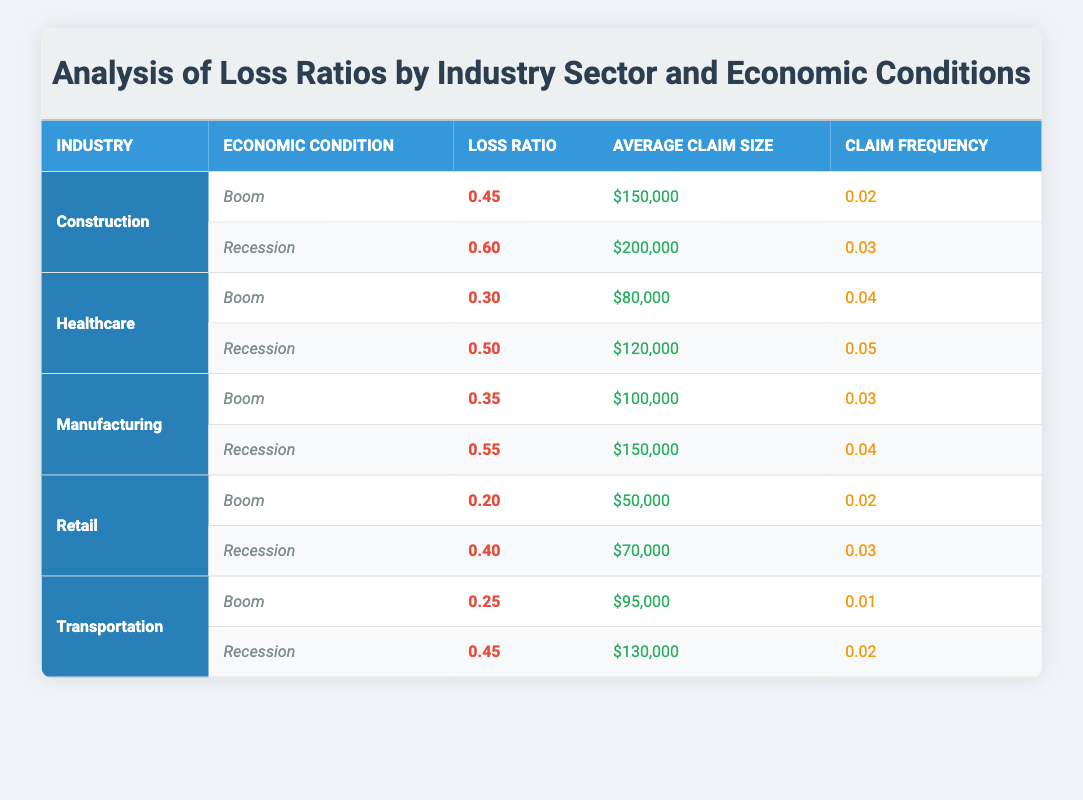What is the loss ratio for the Healthcare industry during a Boom? The table shows that for the Healthcare industry under Boom economic conditions, the loss ratio is listed directly as 0.30.
Answer: 0.30 What is the average claim size for the Construction industry during a Recession? Referring to the Construction industry row under Recession conditions, the average claim size is stated explicitly as $200,000.
Answer: $200,000 Which industry has the highest loss ratio during a Recession? By comparing the loss ratios during Recession for all industries, Construction has a loss ratio of 0.60, which is higher than the others. Therefore, Construction has the highest loss ratio in a Recession.
Answer: Construction What is the difference in loss ratios between the Manufacturing industry during Boom and Recession? The loss ratio for Manufacturing during Boom is 0.35 and during Recession is 0.55. The difference is calculated as 0.55 - 0.35 = 0.20.
Answer: 0.20 Is it true that the average claim size for the Transportation industry is higher during a Boom than during a Recession? In Boom conditions, the average claim size for Transportation is $95,000, while during Recession it is $130,000. Since $95,000 is less than $130,000, the statement is false.
Answer: No Which economic condition shows a higher claim frequency for the Retail industry? The table indicates that the claim frequency for the Retail industry during Boom is 0.02 and during Recession is 0.03. Since 0.03 is greater than 0.02, the Recession shows a higher claim frequency for Retail.
Answer: Recession What is the average loss ratio for the Construction and Healthcare industries during Boom conditions? The loss ratios for Construction and Healthcare during Boom are 0.45 and 0.30, respectively. The average is calculated as (0.45 + 0.30) / 2 = 0.375.
Answer: 0.375 Which industry's loss ratio changed the most from Boom to Recession? To find out which industry has the most significant change, I assess the loss ratios: Construction (0.15), Healthcare (0.20), Manufacturing (0.20), Retail (0.20), and Transportation (0.20). Construction has the greatest change of 0.15.
Answer: Construction 